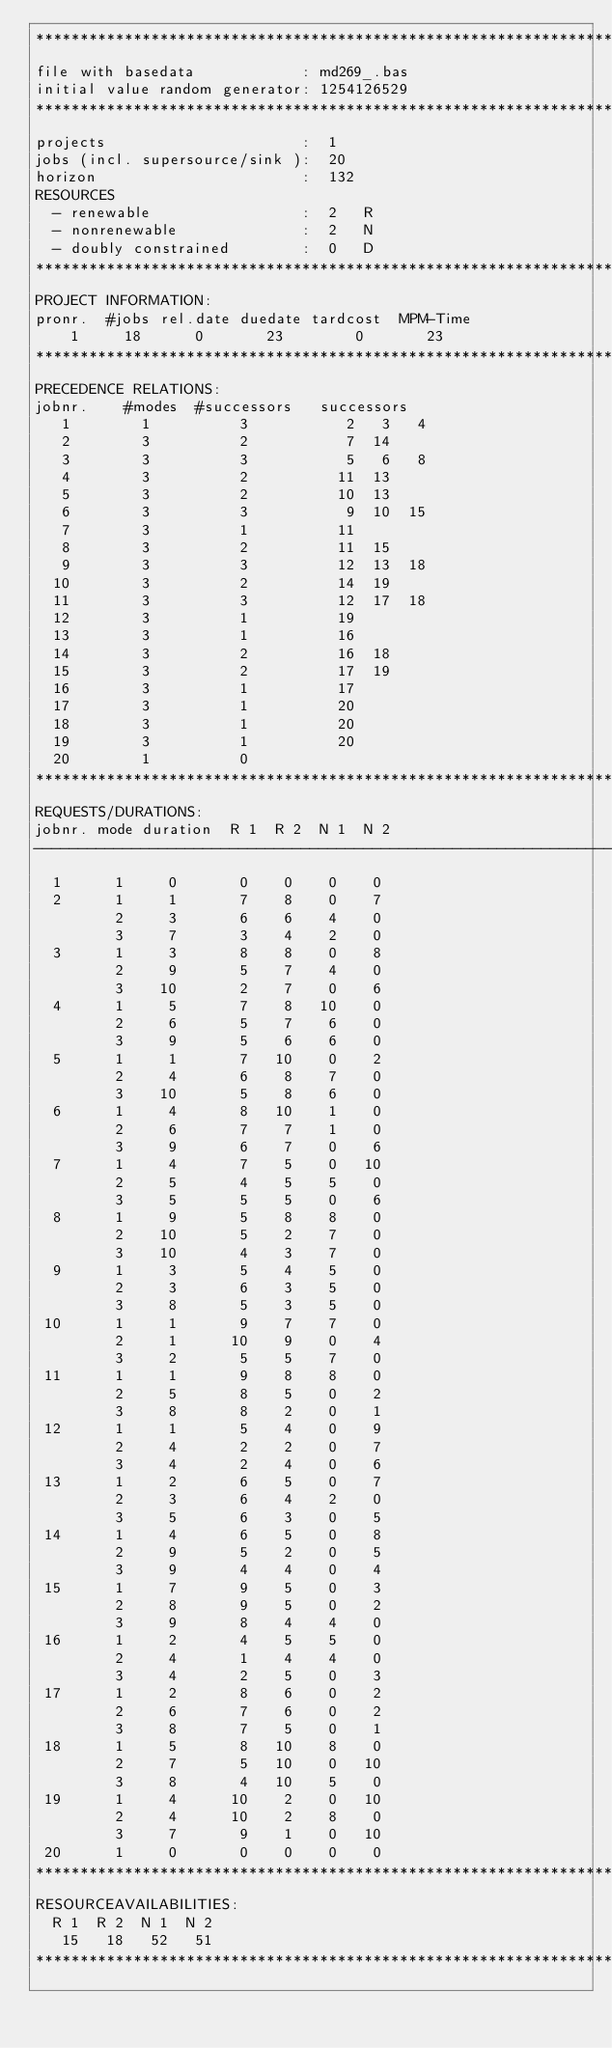<code> <loc_0><loc_0><loc_500><loc_500><_ObjectiveC_>************************************************************************
file with basedata            : md269_.bas
initial value random generator: 1254126529
************************************************************************
projects                      :  1
jobs (incl. supersource/sink ):  20
horizon                       :  132
RESOURCES
  - renewable                 :  2   R
  - nonrenewable              :  2   N
  - doubly constrained        :  0   D
************************************************************************
PROJECT INFORMATION:
pronr.  #jobs rel.date duedate tardcost  MPM-Time
    1     18      0       23        0       23
************************************************************************
PRECEDENCE RELATIONS:
jobnr.    #modes  #successors   successors
   1        1          3           2   3   4
   2        3          2           7  14
   3        3          3           5   6   8
   4        3          2          11  13
   5        3          2          10  13
   6        3          3           9  10  15
   7        3          1          11
   8        3          2          11  15
   9        3          3          12  13  18
  10        3          2          14  19
  11        3          3          12  17  18
  12        3          1          19
  13        3          1          16
  14        3          2          16  18
  15        3          2          17  19
  16        3          1          17
  17        3          1          20
  18        3          1          20
  19        3          1          20
  20        1          0        
************************************************************************
REQUESTS/DURATIONS:
jobnr. mode duration  R 1  R 2  N 1  N 2
------------------------------------------------------------------------
  1      1     0       0    0    0    0
  2      1     1       7    8    0    7
         2     3       6    6    4    0
         3     7       3    4    2    0
  3      1     3       8    8    0    8
         2     9       5    7    4    0
         3    10       2    7    0    6
  4      1     5       7    8   10    0
         2     6       5    7    6    0
         3     9       5    6    6    0
  5      1     1       7   10    0    2
         2     4       6    8    7    0
         3    10       5    8    6    0
  6      1     4       8   10    1    0
         2     6       7    7    1    0
         3     9       6    7    0    6
  7      1     4       7    5    0   10
         2     5       4    5    5    0
         3     5       5    5    0    6
  8      1     9       5    8    8    0
         2    10       5    2    7    0
         3    10       4    3    7    0
  9      1     3       5    4    5    0
         2     3       6    3    5    0
         3     8       5    3    5    0
 10      1     1       9    7    7    0
         2     1      10    9    0    4
         3     2       5    5    7    0
 11      1     1       9    8    8    0
         2     5       8    5    0    2
         3     8       8    2    0    1
 12      1     1       5    4    0    9
         2     4       2    2    0    7
         3     4       2    4    0    6
 13      1     2       6    5    0    7
         2     3       6    4    2    0
         3     5       6    3    0    5
 14      1     4       6    5    0    8
         2     9       5    2    0    5
         3     9       4    4    0    4
 15      1     7       9    5    0    3
         2     8       9    5    0    2
         3     9       8    4    4    0
 16      1     2       4    5    5    0
         2     4       1    4    4    0
         3     4       2    5    0    3
 17      1     2       8    6    0    2
         2     6       7    6    0    2
         3     8       7    5    0    1
 18      1     5       8   10    8    0
         2     7       5   10    0   10
         3     8       4   10    5    0
 19      1     4      10    2    0   10
         2     4      10    2    8    0
         3     7       9    1    0   10
 20      1     0       0    0    0    0
************************************************************************
RESOURCEAVAILABILITIES:
  R 1  R 2  N 1  N 2
   15   18   52   51
************************************************************************
</code> 